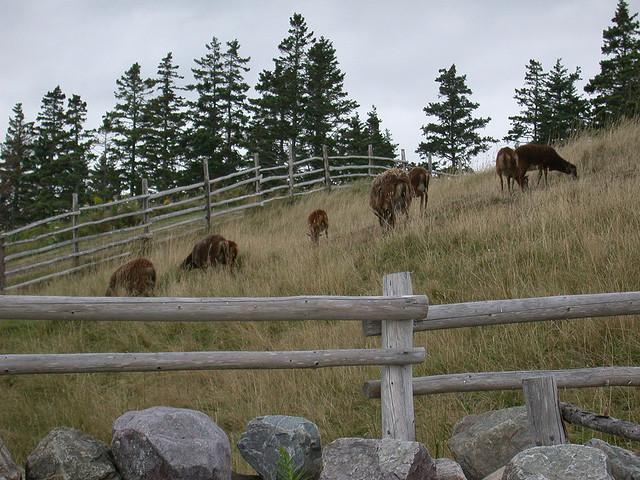How many cows are in the picture?
Give a very brief answer. 2. 